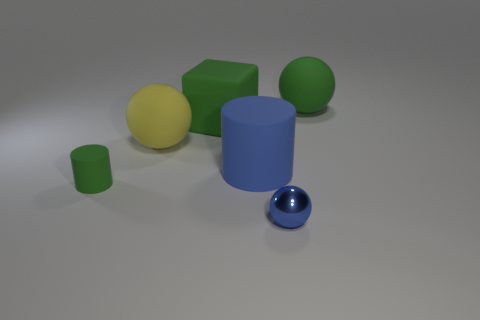What number of large rubber cylinders are the same color as the cube?
Make the answer very short. 0. There is a blue cylinder that is made of the same material as the cube; what size is it?
Ensure brevity in your answer.  Large. How many things are small green matte objects behind the tiny blue metal thing or large spheres?
Your response must be concise. 3. There is a big rubber ball that is left of the big green ball; is it the same color as the small shiny ball?
Make the answer very short. No. What is the size of the other thing that is the same shape as the blue rubber object?
Offer a terse response. Small. The matte sphere that is on the right side of the large green matte object that is on the left side of the big rubber thing that is on the right side of the small metal sphere is what color?
Make the answer very short. Green. Is the material of the tiny blue thing the same as the green cylinder?
Make the answer very short. No. Are there any big green rubber balls in front of the blue rubber object right of the ball to the left of the blue metal ball?
Make the answer very short. No. Do the metal ball and the tiny cylinder have the same color?
Ensure brevity in your answer.  No. Is the number of tiny things less than the number of tiny red shiny objects?
Give a very brief answer. No. 